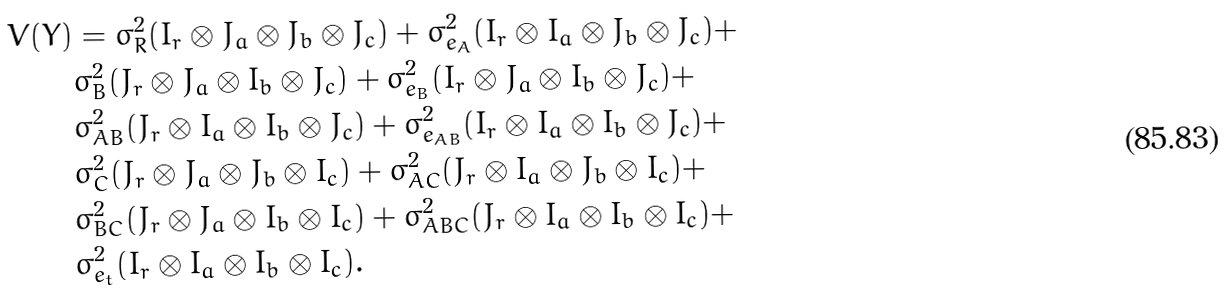<formula> <loc_0><loc_0><loc_500><loc_500>V ( Y ) & = \sigma _ { R } ^ { 2 } ( I _ { r } \otimes J _ { a } \otimes J _ { b } \otimes J _ { c } ) + \sigma _ { e _ { A } } ^ { 2 } ( I _ { r } \otimes I _ { a } \otimes J _ { b } \otimes J _ { c } ) + \\ & \sigma _ { B } ^ { 2 } ( J _ { r } \otimes J _ { a } \otimes I _ { b } \otimes J _ { c } ) + \sigma _ { e _ { B } } ^ { 2 } ( I _ { r } \otimes J _ { a } \otimes I _ { b } \otimes J _ { c } ) + \\ & \sigma _ { A B } ^ { 2 } ( J _ { r } \otimes I _ { a } \otimes I _ { b } \otimes J _ { c } ) + \sigma _ { e _ { A B } } ^ { 2 } ( I _ { r } \otimes I _ { a } \otimes I _ { b } \otimes J _ { c } ) + \\ & \sigma _ { C } ^ { 2 } ( J _ { r } \otimes J _ { a } \otimes J _ { b } \otimes I _ { c } ) + \sigma _ { A C } ^ { 2 } ( J _ { r } \otimes I _ { a } \otimes J _ { b } \otimes I _ { c } ) + \\ & \sigma _ { B C } ^ { 2 } ( J _ { r } \otimes J _ { a } \otimes I _ { b } \otimes I _ { c } ) + \sigma _ { A B C } ^ { 2 } ( J _ { r } \otimes I _ { a } \otimes I _ { b } \otimes I _ { c } ) + \\ & \sigma _ { e _ { t } } ^ { 2 } ( I _ { r } \otimes I _ { a } \otimes I _ { b } \otimes I _ { c } ) .</formula> 